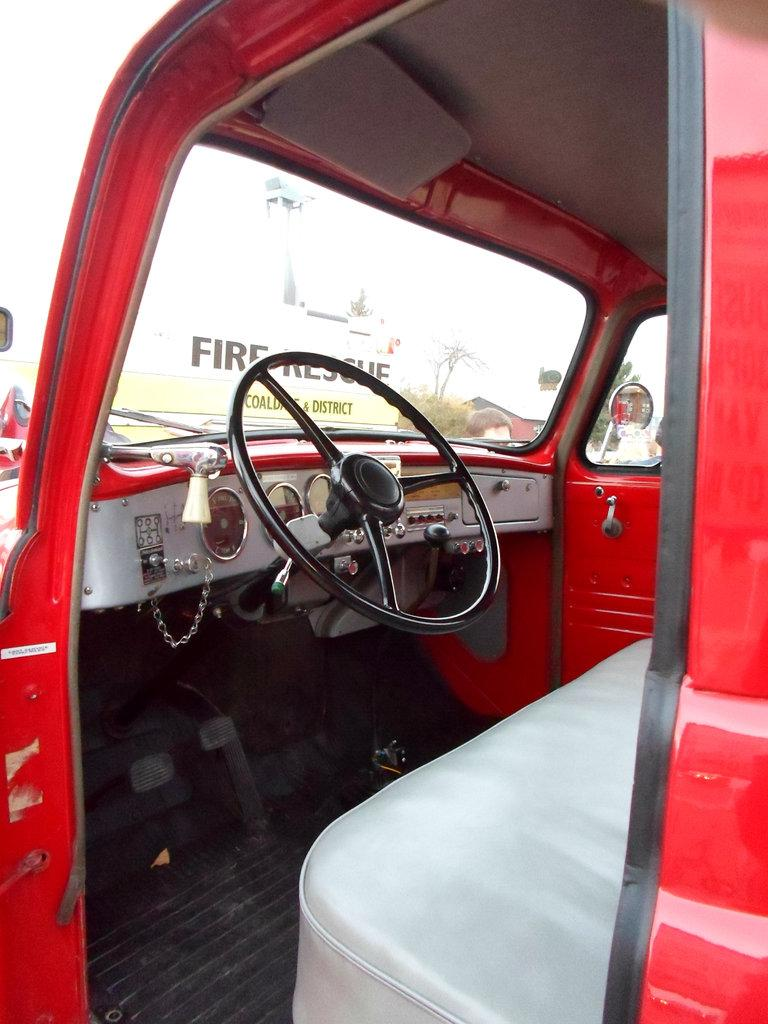What is the main object in the image? There is an object in the image, but the specific type is not mentioned in the facts. What feature does the object have that allows someone to sit on it? The object has a seat. What feature does the object have that allows someone to control its movement? The object has a steering wheel. What feature does the object have that is related to electricity? The object has electric meters. What advice does the coach give to the team in the image? There is no coach or team present in the image, so no advice can be given. 